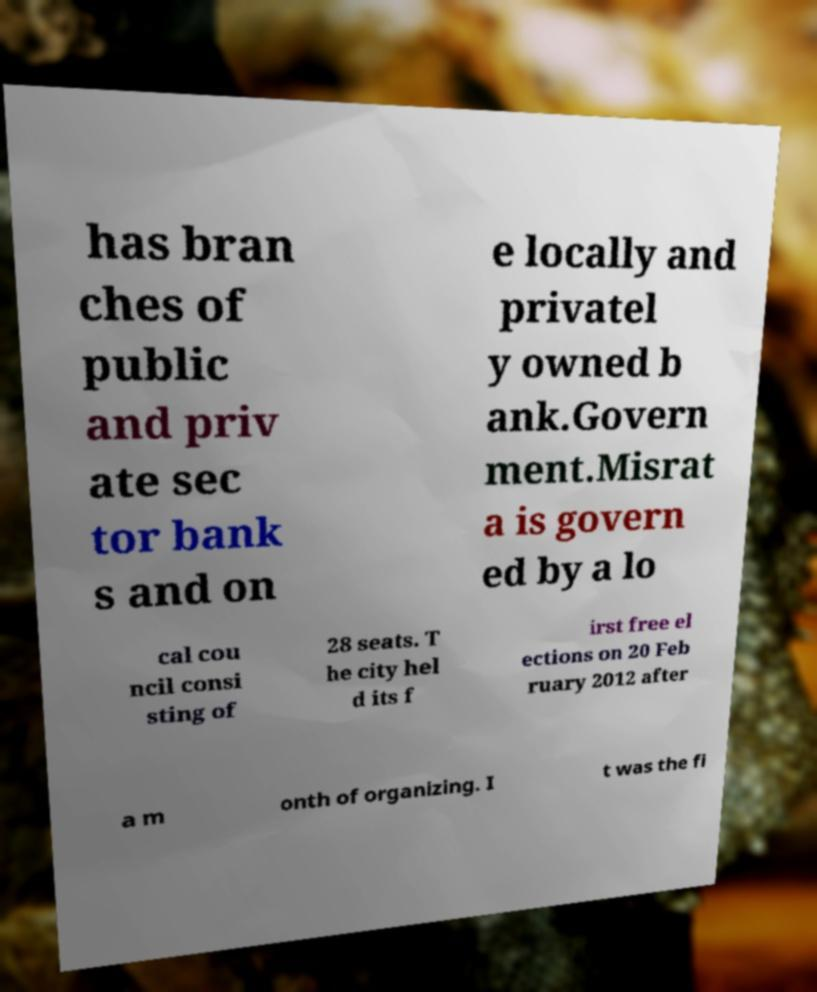I need the written content from this picture converted into text. Can you do that? has bran ches of public and priv ate sec tor bank s and on e locally and privatel y owned b ank.Govern ment.Misrat a is govern ed by a lo cal cou ncil consi sting of 28 seats. T he city hel d its f irst free el ections on 20 Feb ruary 2012 after a m onth of organizing. I t was the fi 